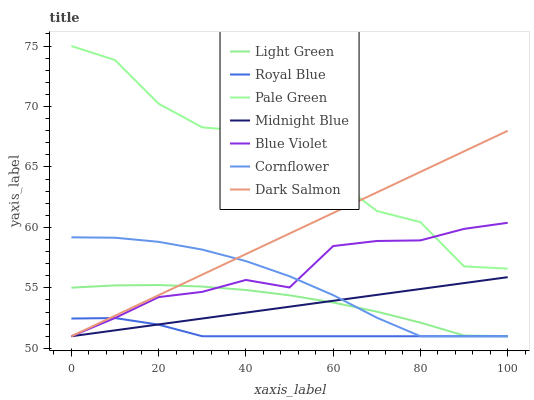Does Royal Blue have the minimum area under the curve?
Answer yes or no. Yes. Does Pale Green have the maximum area under the curve?
Answer yes or no. Yes. Does Midnight Blue have the minimum area under the curve?
Answer yes or no. No. Does Midnight Blue have the maximum area under the curve?
Answer yes or no. No. Is Midnight Blue the smoothest?
Answer yes or no. Yes. Is Pale Green the roughest?
Answer yes or no. Yes. Is Dark Salmon the smoothest?
Answer yes or no. No. Is Dark Salmon the roughest?
Answer yes or no. No. Does Cornflower have the lowest value?
Answer yes or no. Yes. Does Pale Green have the lowest value?
Answer yes or no. No. Does Pale Green have the highest value?
Answer yes or no. Yes. Does Midnight Blue have the highest value?
Answer yes or no. No. Is Royal Blue less than Pale Green?
Answer yes or no. Yes. Is Pale Green greater than Cornflower?
Answer yes or no. Yes. Does Light Green intersect Midnight Blue?
Answer yes or no. Yes. Is Light Green less than Midnight Blue?
Answer yes or no. No. Is Light Green greater than Midnight Blue?
Answer yes or no. No. Does Royal Blue intersect Pale Green?
Answer yes or no. No. 